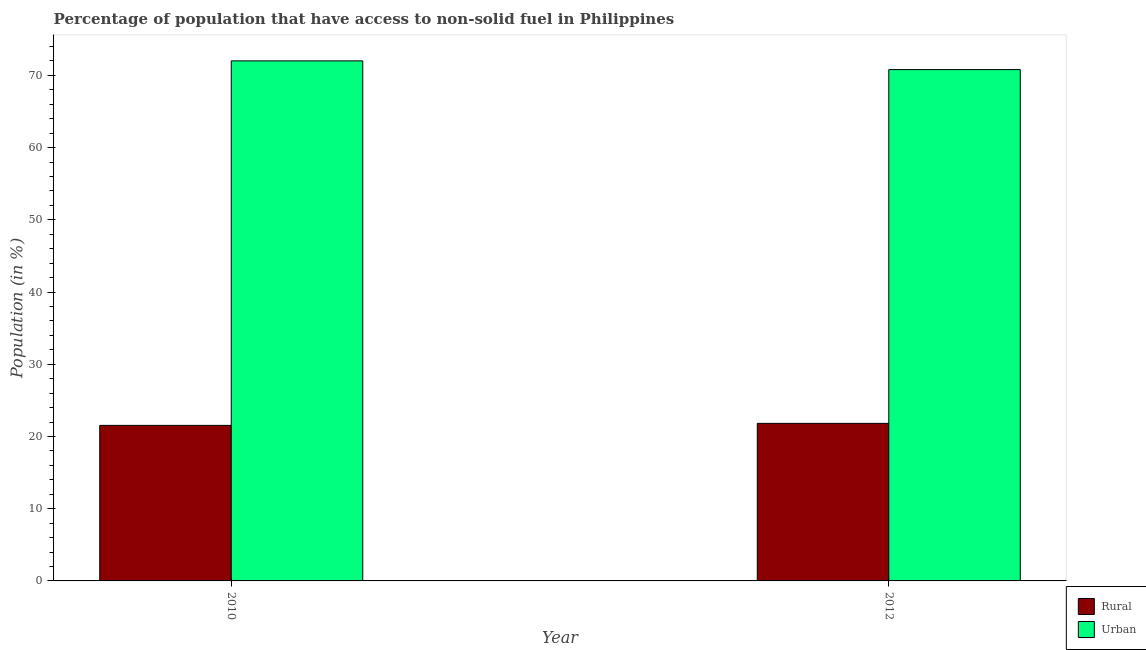How many different coloured bars are there?
Make the answer very short. 2. Are the number of bars per tick equal to the number of legend labels?
Offer a very short reply. Yes. How many bars are there on the 1st tick from the left?
Offer a terse response. 2. What is the label of the 1st group of bars from the left?
Keep it short and to the point. 2010. What is the rural population in 2010?
Your answer should be very brief. 21.54. Across all years, what is the maximum rural population?
Keep it short and to the point. 21.82. Across all years, what is the minimum rural population?
Ensure brevity in your answer.  21.54. In which year was the urban population maximum?
Offer a very short reply. 2010. What is the total rural population in the graph?
Provide a succinct answer. 43.35. What is the difference between the urban population in 2010 and that in 2012?
Your answer should be compact. 1.2. What is the difference between the rural population in 2012 and the urban population in 2010?
Keep it short and to the point. 0.28. What is the average rural population per year?
Offer a terse response. 21.68. In the year 2012, what is the difference between the rural population and urban population?
Keep it short and to the point. 0. What is the ratio of the rural population in 2010 to that in 2012?
Provide a short and direct response. 0.99. What does the 2nd bar from the left in 2012 represents?
Offer a terse response. Urban. What does the 2nd bar from the right in 2010 represents?
Offer a terse response. Rural. How many bars are there?
Your answer should be compact. 4. Are all the bars in the graph horizontal?
Your response must be concise. No. How many years are there in the graph?
Make the answer very short. 2. Does the graph contain any zero values?
Offer a very short reply. No. Does the graph contain grids?
Provide a succinct answer. No. Where does the legend appear in the graph?
Give a very brief answer. Bottom right. How many legend labels are there?
Offer a very short reply. 2. How are the legend labels stacked?
Give a very brief answer. Vertical. What is the title of the graph?
Make the answer very short. Percentage of population that have access to non-solid fuel in Philippines. Does "Non-residents" appear as one of the legend labels in the graph?
Keep it short and to the point. No. What is the label or title of the X-axis?
Provide a succinct answer. Year. What is the Population (in %) in Rural in 2010?
Give a very brief answer. 21.54. What is the Population (in %) of Urban in 2010?
Keep it short and to the point. 72.01. What is the Population (in %) of Rural in 2012?
Keep it short and to the point. 21.82. What is the Population (in %) of Urban in 2012?
Make the answer very short. 70.8. Across all years, what is the maximum Population (in %) in Rural?
Offer a terse response. 21.82. Across all years, what is the maximum Population (in %) of Urban?
Ensure brevity in your answer.  72.01. Across all years, what is the minimum Population (in %) of Rural?
Offer a very short reply. 21.54. Across all years, what is the minimum Population (in %) of Urban?
Your answer should be very brief. 70.8. What is the total Population (in %) of Rural in the graph?
Provide a succinct answer. 43.35. What is the total Population (in %) of Urban in the graph?
Keep it short and to the point. 142.81. What is the difference between the Population (in %) of Rural in 2010 and that in 2012?
Offer a terse response. -0.28. What is the difference between the Population (in %) of Urban in 2010 and that in 2012?
Make the answer very short. 1.21. What is the difference between the Population (in %) in Rural in 2010 and the Population (in %) in Urban in 2012?
Your answer should be compact. -49.27. What is the average Population (in %) in Rural per year?
Offer a terse response. 21.68. What is the average Population (in %) of Urban per year?
Offer a very short reply. 71.41. In the year 2010, what is the difference between the Population (in %) in Rural and Population (in %) in Urban?
Your answer should be very brief. -50.47. In the year 2012, what is the difference between the Population (in %) of Rural and Population (in %) of Urban?
Give a very brief answer. -48.99. What is the ratio of the Population (in %) of Rural in 2010 to that in 2012?
Provide a short and direct response. 0.99. What is the difference between the highest and the second highest Population (in %) in Rural?
Your response must be concise. 0.28. What is the difference between the highest and the second highest Population (in %) of Urban?
Provide a short and direct response. 1.21. What is the difference between the highest and the lowest Population (in %) of Rural?
Ensure brevity in your answer.  0.28. What is the difference between the highest and the lowest Population (in %) in Urban?
Offer a terse response. 1.21. 